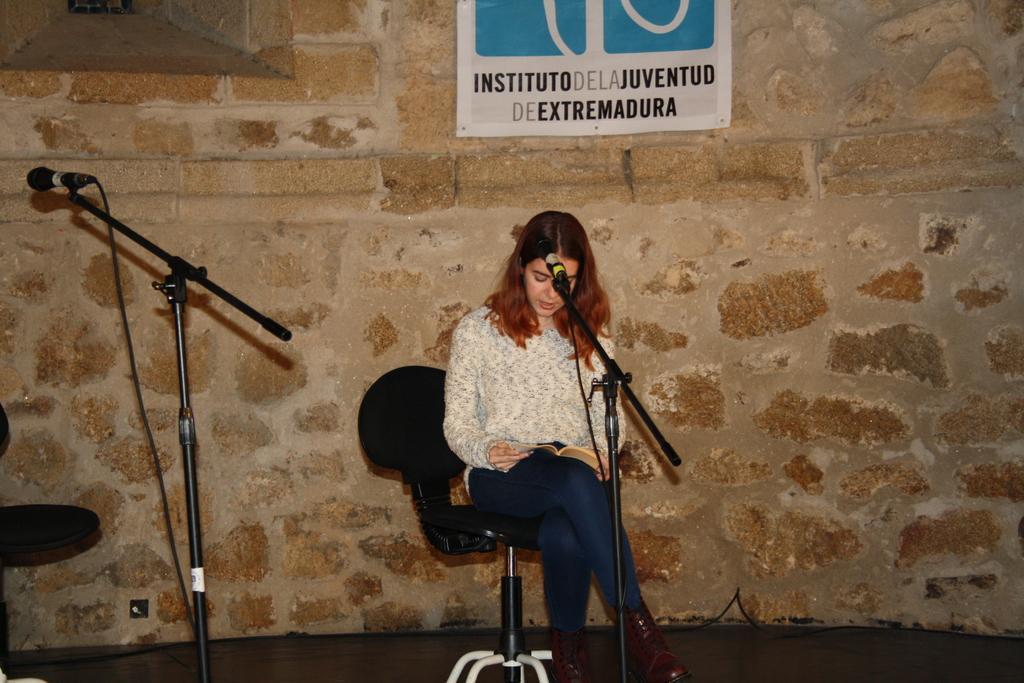Describe this image in one or two sentences. There is one woman sitting on the chair and holding a book in the middle of this image. We can see Mikes at the bottom of this image and there is a wall in the background. We can see a poster attached to it. 